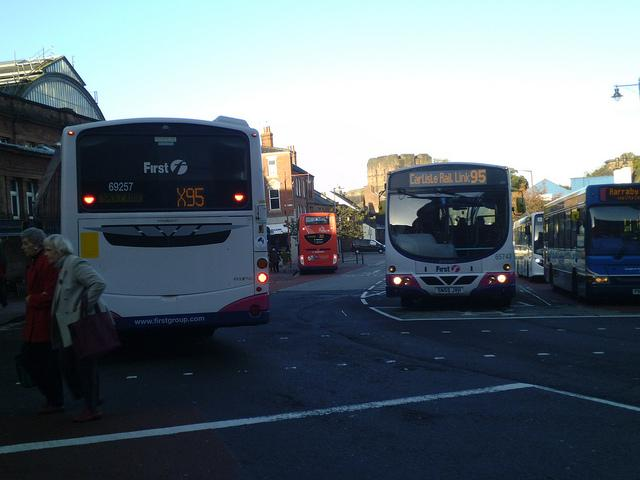In which area do these buses run? carlisle 